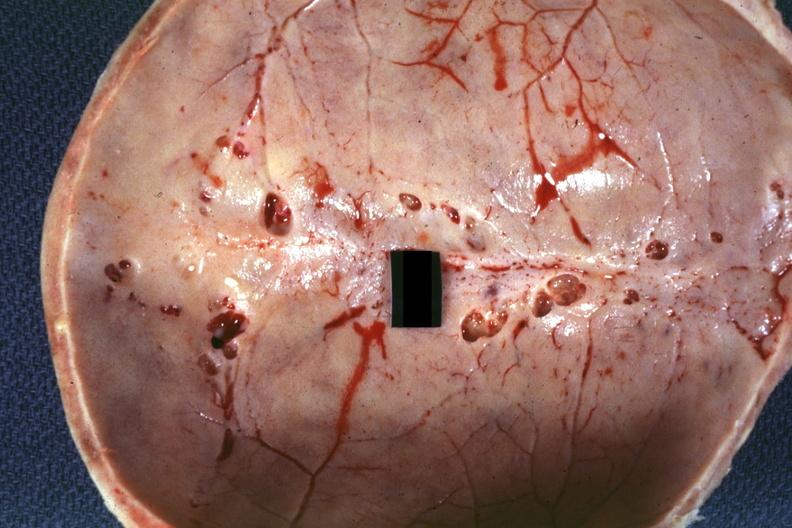what is present?
Answer the question using a single word or phrase. Bone, calvarium 